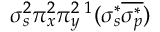Convert formula to latex. <formula><loc_0><loc_0><loc_500><loc_500>\sigma _ { s } ^ { 2 } \pi _ { x } ^ { 2 } \pi _ { y } ^ { 2 \, ^ { 1 } ( \sigma _ { s } ^ { * } \overline { { \sigma _ { p } ^ { * } } } )</formula> 